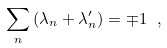Convert formula to latex. <formula><loc_0><loc_0><loc_500><loc_500>\sum _ { n } \left ( \lambda _ { n } + \lambda _ { n } ^ { \prime } \right ) = \mp 1 \ ,</formula> 